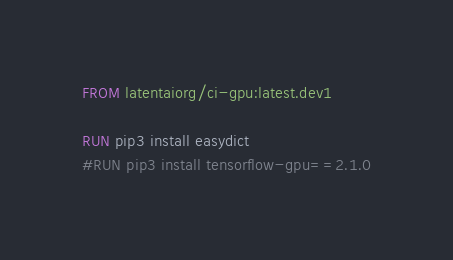Convert code to text. <code><loc_0><loc_0><loc_500><loc_500><_Dockerfile_>FROM latentaiorg/ci-gpu:latest.dev1

RUN pip3 install easydict
#RUN pip3 install tensorflow-gpu==2.1.0

</code> 